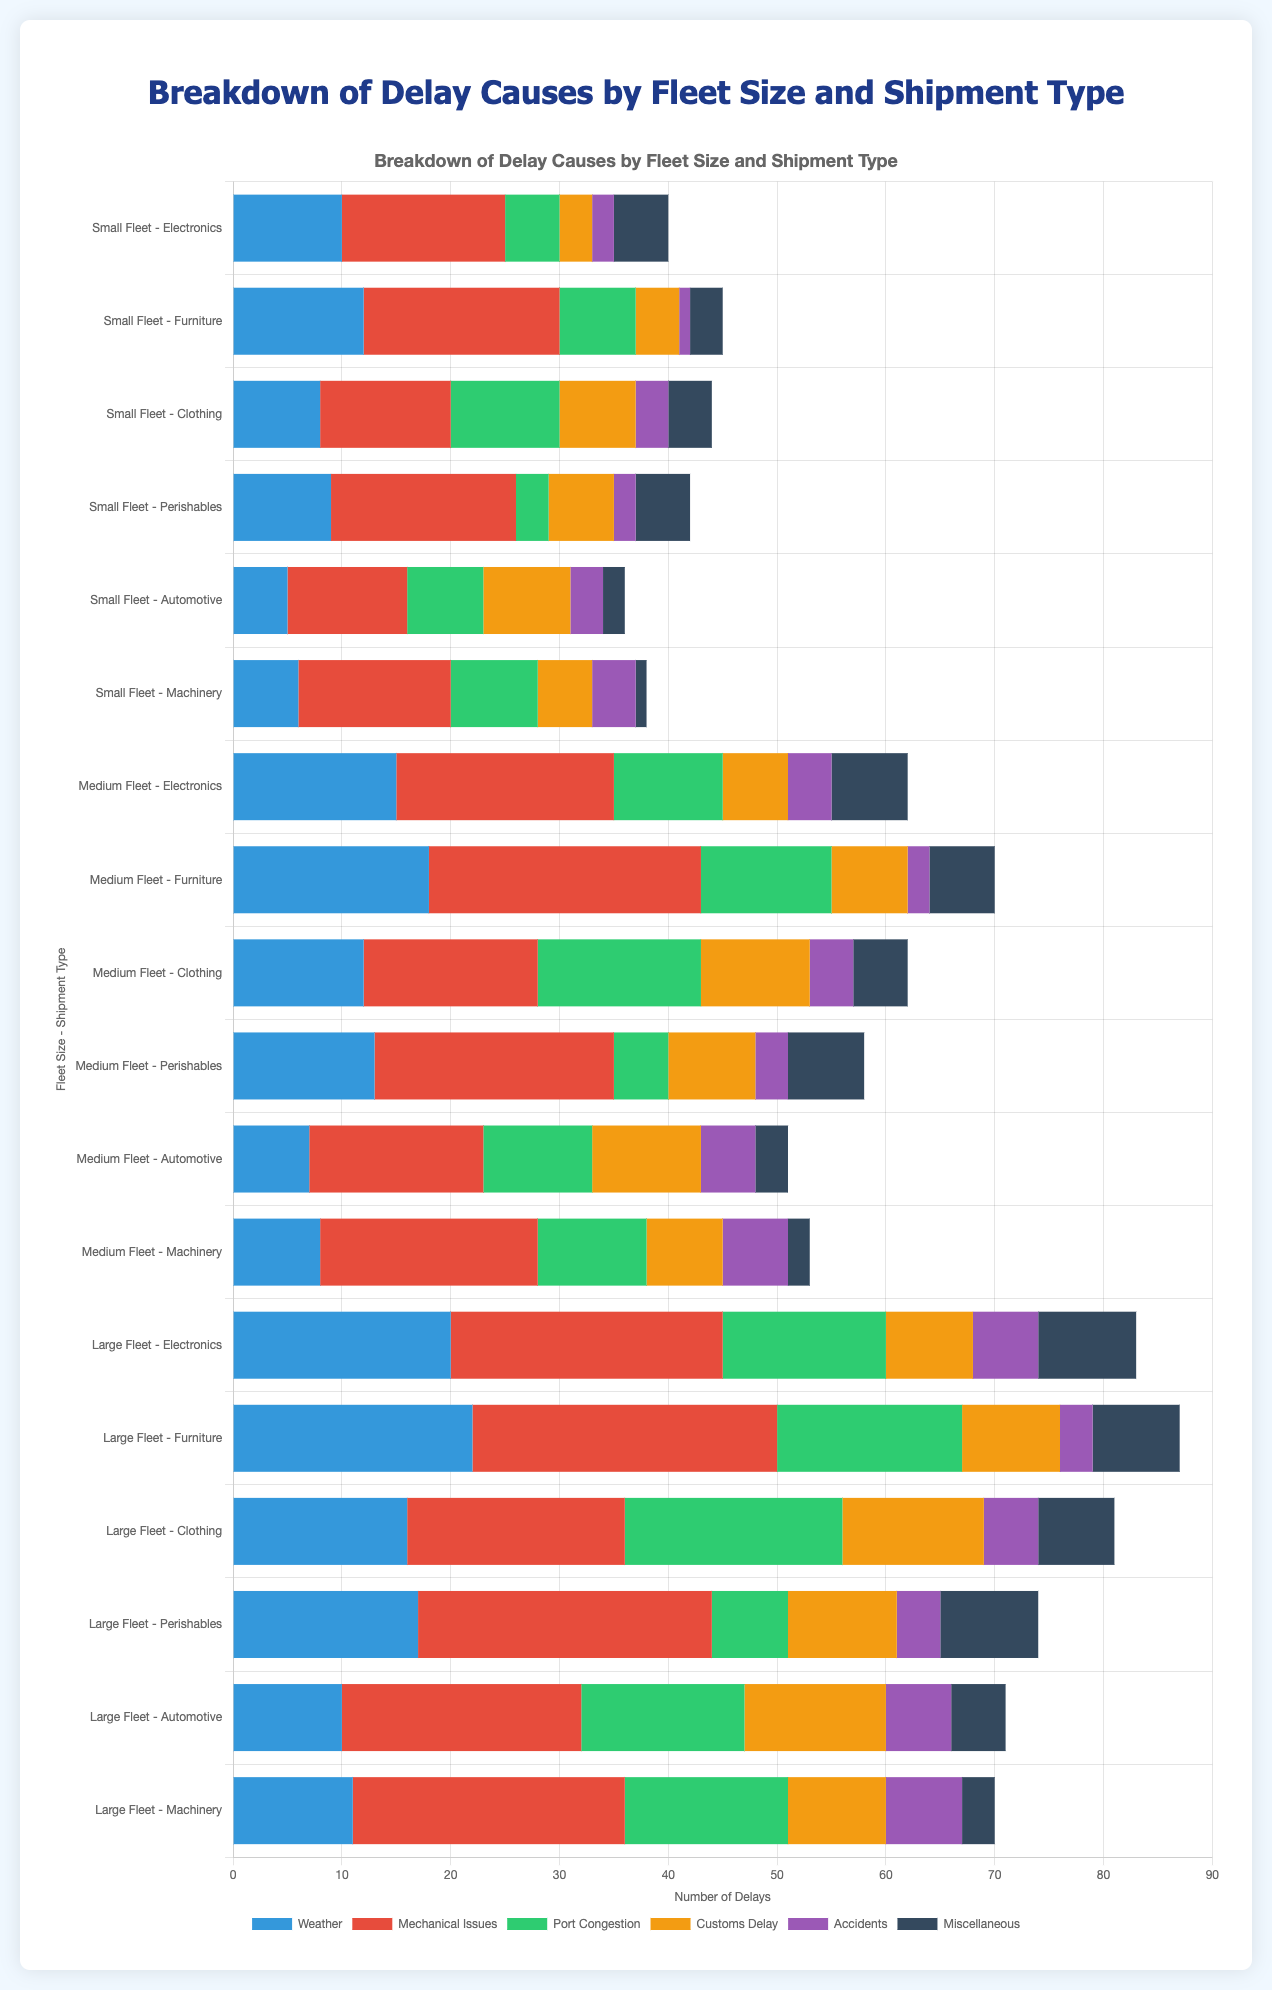Which fleet and shipment type experienced the most delays due to weather? To find the answer, look at the section of the chart representing "Weather" delays. Compare the lengths of these sections across all fleet sizes and shipment types. The longest "Weather" section corresponds to the largest number of weather-related delays. For Large Fleet - Furniture, the bar length reaches 22, which is the highest among all.
Answer: Large Fleet - Furniture Across all fleet sizes, which shipment type had the highest number of delays due to port congestion? Examine the sections for "Port Congestion" delays across all shipment types and fleet sizes. The highest number occurs in Large Fleet - Clothing with 20 delays.
Answer: Clothing in Large Fleet Which shipment type and fleet size combination experienced the lowest number of accidents? Look at the bar segments for "Accidents" and identify the shortest one. The shortest segment for accidents is for Small Fleet - Furniture, which has a value of 1.
Answer: Furniture in Small Fleet What is the total number of delays for the Electronic shipments across all fleet sizes? Add the total delays for Electronics in each fleet: Small Fleet (40), Medium Fleet (62), and Large Fleet (83). The total is 40 + 62 + 83 = 185.
Answer: 185 How do the delays due to mechanical issues compare between Medium Fleet - Automotive and Small Fleet - Machinery? Find and compare the "Mechanical Issues" sections for both categories. Medium Fleet - Automotive has 16 delays, and Small Fleet - Machinery has 14 delays. Thus, Medium Fleet - Automotive has 2 more delays.
Answer: Medium Fleet - Automotive has 2 more delays For Small Fleets, which shipment type had the highest sum of delays from port congestion and customs delay combined? Calculate the sum of delays for "Port Congestion" and "Customs Delay" for Small Fleet shipment types. The sums are:
- Electronics: 5 + 3 = 8
- Furniture: 7 + 4 = 11
- Clothing: 10 + 7 = 17
- Perishables: 3 + 6 = 9
- Automotive: 7 + 8 = 15
- Machinery: 8 + 5 = 13
The maximum is 17.
Answer: Clothing Which cause of delay has the shortest total length of its segments across all shipment types in the Large Fleet? Calculate the sum of lengths for each delay cause across all shipment types in the Large Fleet. The segments are summed as follows:
- Weather: 20 + 22 + 16 + 17 + 10 + 11 = 96
- Mechanical Issues: 25 + 28 + 20 + 27 + 22 + 25 = 147
- Port Congestion: 15 + 17 + 20 + 7 + 15 + 15 = 89
- Customs Delay: 8 + 9 + 13 + 10 + 13 + 9 = 62
- Accidents: 6 + 3 + 5 + 4 + 6 + 7 = 31
- Miscellaneous: 9 + 8 + 7 + 9 + 5 + 3 = 41
The shortest length is for "Accidents".
Answer: Accidents What is the average number of mechanical issues delays for Perishables shipments across all fleet sizes? Calculate the average of delays due to "Mechanical Issues" for Perishables across all fleets: Small Fleet (17), Medium Fleet (22), and Large Fleet (27). The average is (17 + 22 + 27) / 3 = 22.
Answer: 22 For Medium Fleet, which shipment type had the highest sum of delays from weather and accidents combined? Calculate the total of delays for "Weather" and "Accidents" for Medium Fleet shipment types. The sums are:
- Electronics: 15 + 4 = 19
- Furniture: 18 + 2 = 20
- Clothing: 12 + 4 = 16
- Perishables: 13 + 3 = 16
- Automotive: 7 + 5 = 12
- Machinery: 8 + 6 = 14
The maximum is for Furniture with 20 delays.
Answer: Furniture 